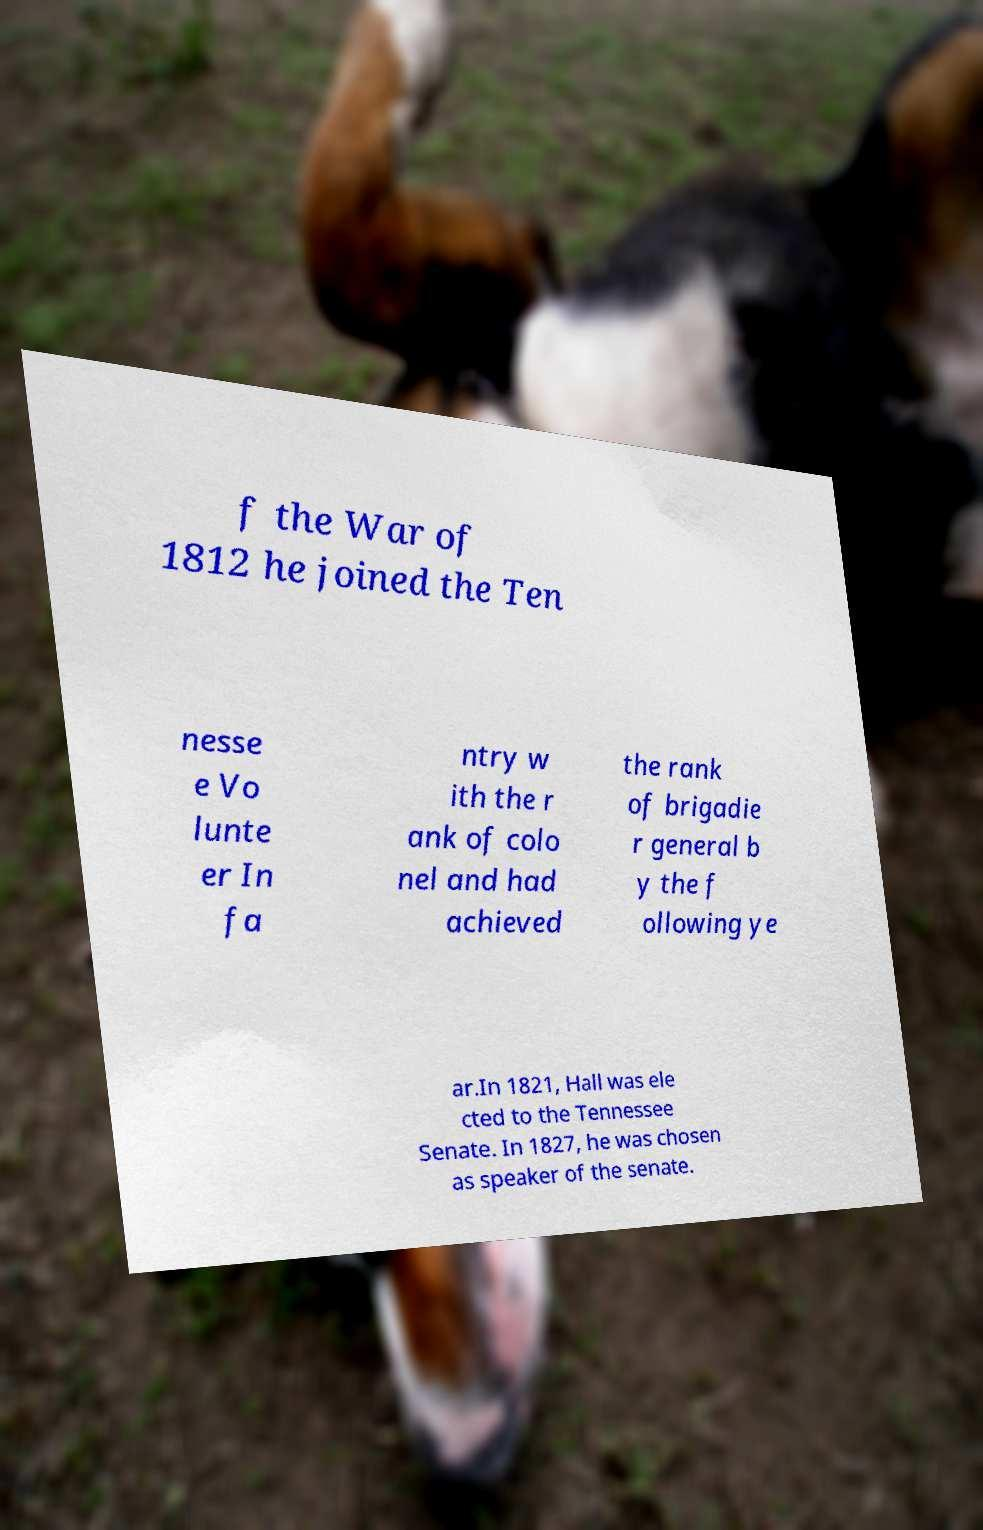Please read and relay the text visible in this image. What does it say? f the War of 1812 he joined the Ten nesse e Vo lunte er In fa ntry w ith the r ank of colo nel and had achieved the rank of brigadie r general b y the f ollowing ye ar.In 1821, Hall was ele cted to the Tennessee Senate. In 1827, he was chosen as speaker of the senate. 